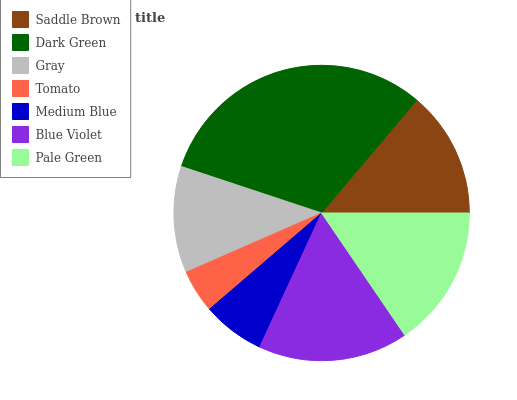Is Tomato the minimum?
Answer yes or no. Yes. Is Dark Green the maximum?
Answer yes or no. Yes. Is Gray the minimum?
Answer yes or no. No. Is Gray the maximum?
Answer yes or no. No. Is Dark Green greater than Gray?
Answer yes or no. Yes. Is Gray less than Dark Green?
Answer yes or no. Yes. Is Gray greater than Dark Green?
Answer yes or no. No. Is Dark Green less than Gray?
Answer yes or no. No. Is Saddle Brown the high median?
Answer yes or no. Yes. Is Saddle Brown the low median?
Answer yes or no. Yes. Is Blue Violet the high median?
Answer yes or no. No. Is Blue Violet the low median?
Answer yes or no. No. 